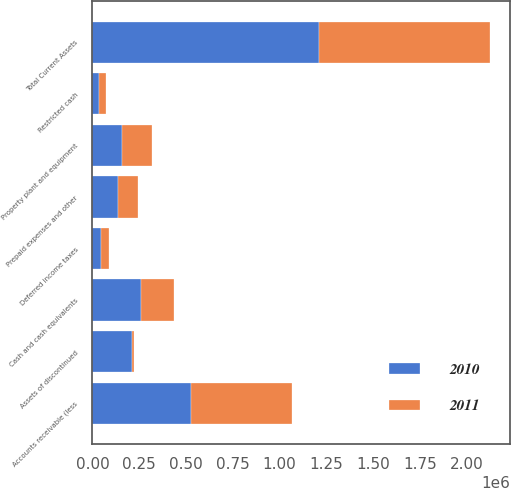<chart> <loc_0><loc_0><loc_500><loc_500><stacked_bar_chart><ecel><fcel>Cash and cash equivalents<fcel>Restricted cash<fcel>Accounts receivable (less<fcel>Deferred income taxes<fcel>Prepaid expenses and other<fcel>Assets of discontinued<fcel>Total Current Assets<fcel>Property plant and equipment<nl><fcel>2010<fcel>258693<fcel>35105<fcel>524326<fcel>44225<fcel>136905<fcel>213208<fcel>1.21246e+06<fcel>158375<nl><fcel>2011<fcel>179845<fcel>35110<fcel>543467<fcel>43235<fcel>105537<fcel>7256<fcel>914450<fcel>158375<nl></chart> 